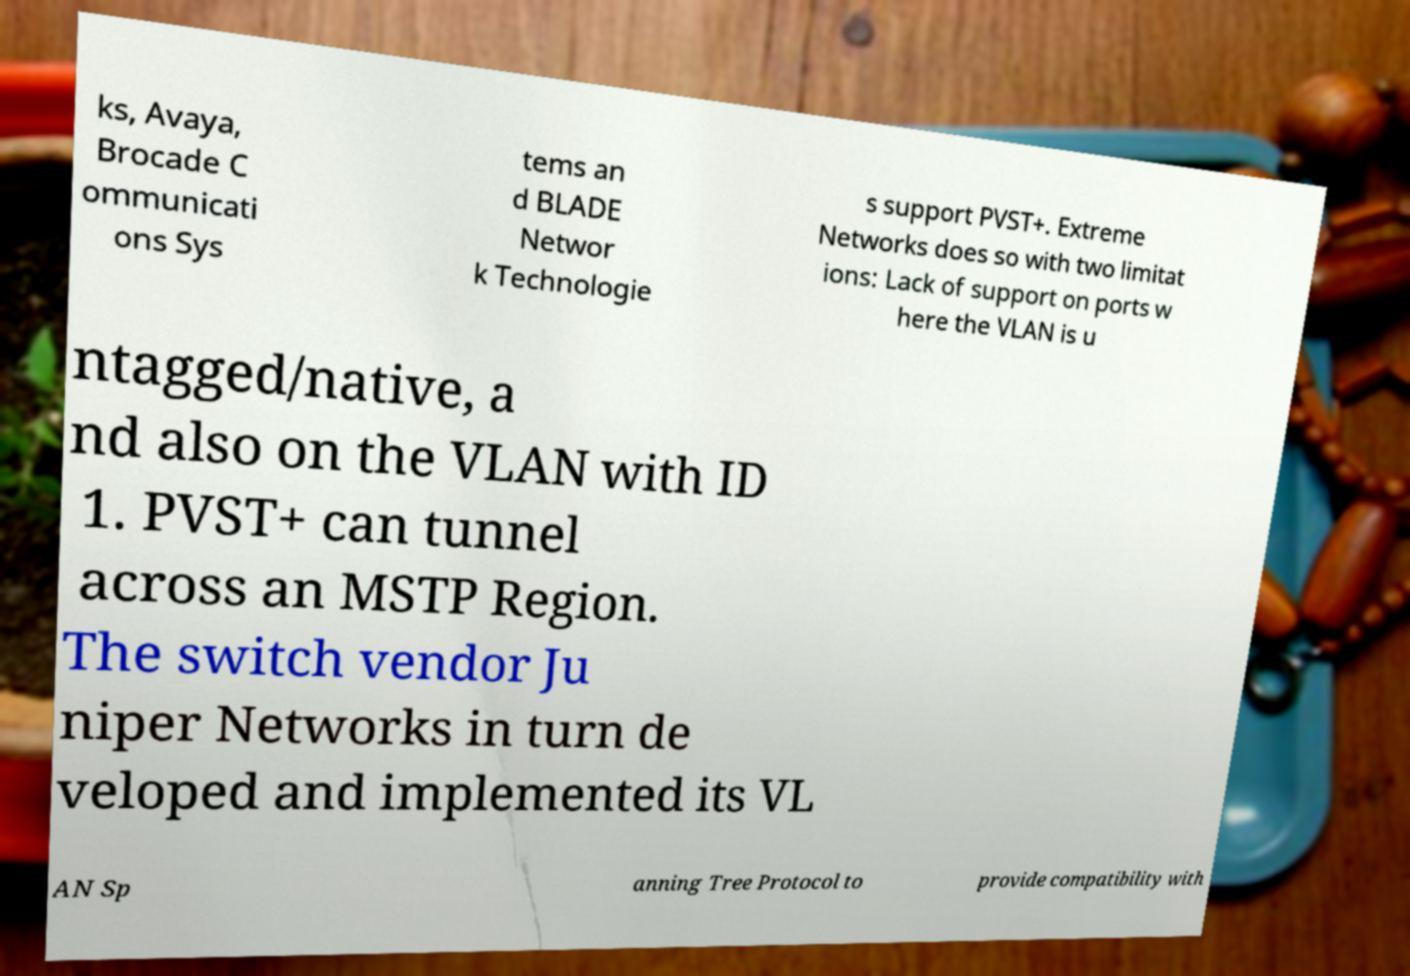Please read and relay the text visible in this image. What does it say? ks, Avaya, Brocade C ommunicati ons Sys tems an d BLADE Networ k Technologie s support PVST+. Extreme Networks does so with two limitat ions: Lack of support on ports w here the VLAN is u ntagged/native, a nd also on the VLAN with ID 1. PVST+ can tunnel across an MSTP Region. The switch vendor Ju niper Networks in turn de veloped and implemented its VL AN Sp anning Tree Protocol to provide compatibility with 